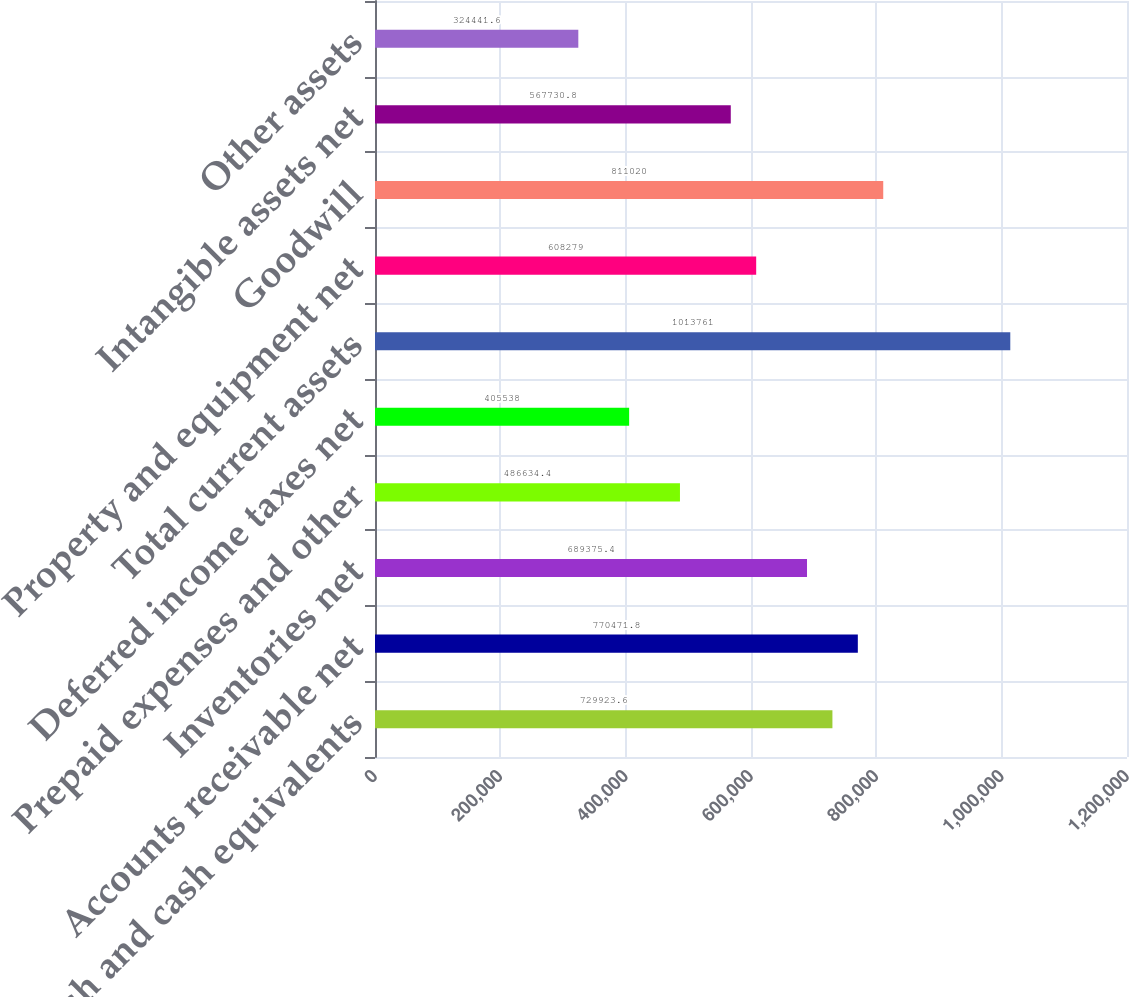Convert chart. <chart><loc_0><loc_0><loc_500><loc_500><bar_chart><fcel>Cash and cash equivalents<fcel>Accounts receivable net<fcel>Inventories net<fcel>Prepaid expenses and other<fcel>Deferred income taxes net<fcel>Total current assets<fcel>Property and equipment net<fcel>Goodwill<fcel>Intangible assets net<fcel>Other assets<nl><fcel>729924<fcel>770472<fcel>689375<fcel>486634<fcel>405538<fcel>1.01376e+06<fcel>608279<fcel>811020<fcel>567731<fcel>324442<nl></chart> 